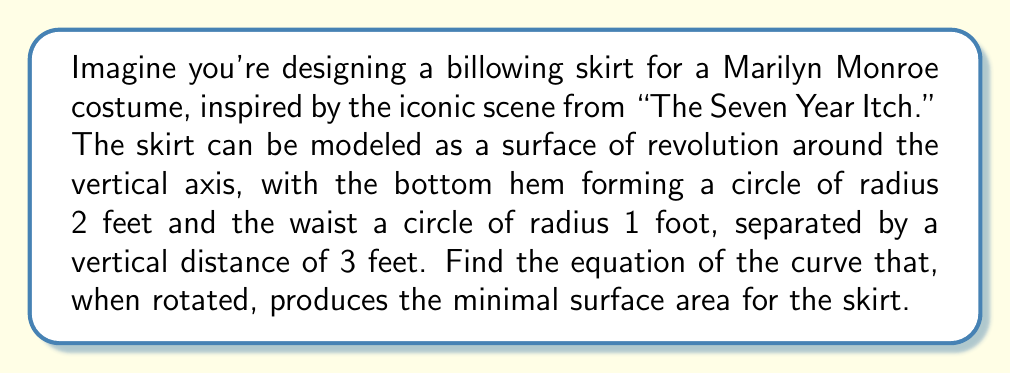Can you solve this math problem? To solve this problem, we'll use the calculus of variations to find the curve that minimizes the surface area when rotated around the vertical axis.

1. Let's define our coordinate system with the z-axis as the vertical axis, and let r(z) be the radius of the skirt at height z.

2. The surface area of a surface of revolution is given by the formula:

   $$A = 2\pi \int_0^3 r(z) \sqrt{1 + [r'(z)]^2} dz$$

3. To minimize this integral, we need to solve the Euler-Lagrange equation:

   $$\frac{\partial F}{\partial r} - \frac{d}{dz}\left(\frac{\partial F}{\partial r'}\right) = 0$$

   where $F = r\sqrt{1 + (r')^2}$

4. Calculating the partial derivatives:

   $$\frac{\partial F}{\partial r} = \sqrt{1 + (r')^2}$$
   $$\frac{\partial F}{\partial r'} = \frac{rr'}{\sqrt{1 + (r')^2}}$$

5. Substituting into the Euler-Lagrange equation:

   $$\sqrt{1 + (r')^2} - \frac{d}{dz}\left(\frac{rr'}{\sqrt{1 + (r')^2}}\right) = 0$$

6. This differential equation can be simplified to:

   $$\frac{r}{\sqrt{1 + (r')^2}} = c$$

   where c is a constant.

7. Rearranging this equation:

   $$r' = \pm \sqrt{\frac{r^2}{c^2} - 1}$$

8. The solution to this differential equation is a catenary curve:

   $$r(z) = c \cosh\left(\frac{z-a}{c}\right)$$

   where a is another constant.

9. To find c and a, we use the boundary conditions:
   r(0) = 2 and r(3) = 1

10. Solving these equations:

    $$2 = c \cosh(-a/c)$$
    $$1 = c \cosh((3-a)/c)$$

11. While these equations don't have a closed-form solution, we can solve them numerically to find:

    c ≈ 1.2756 and a ≈ 1.7244

Therefore, the equation of the curve that produces the minimal surface area when rotated around the z-axis is:

$$r(z) = 1.2756 \cosh\left(\frac{z-1.7244}{1.2756}\right)$$
Answer: $r(z) = 1.2756 \cosh\left(\frac{z-1.7244}{1.2756}\right)$ 